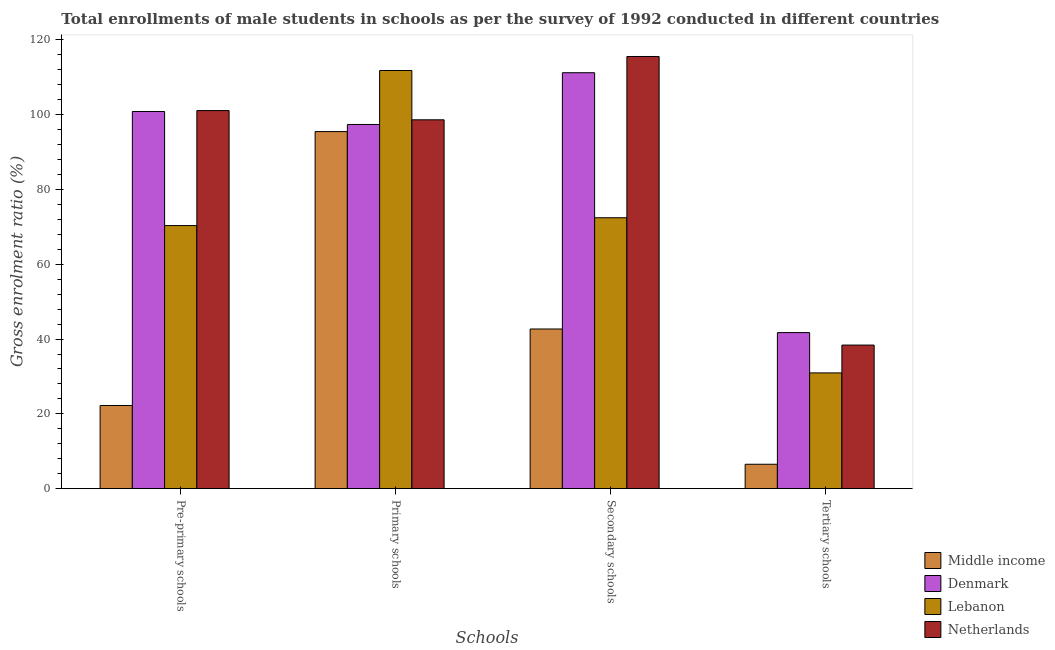What is the label of the 3rd group of bars from the left?
Your response must be concise. Secondary schools. What is the gross enrolment ratio(male) in secondary schools in Netherlands?
Your response must be concise. 115.55. Across all countries, what is the maximum gross enrolment ratio(male) in secondary schools?
Give a very brief answer. 115.55. Across all countries, what is the minimum gross enrolment ratio(male) in secondary schools?
Provide a short and direct response. 42.69. In which country was the gross enrolment ratio(male) in pre-primary schools maximum?
Provide a short and direct response. Netherlands. What is the total gross enrolment ratio(male) in pre-primary schools in the graph?
Make the answer very short. 294.52. What is the difference between the gross enrolment ratio(male) in primary schools in Netherlands and that in Lebanon?
Your answer should be very brief. -13.18. What is the difference between the gross enrolment ratio(male) in primary schools in Lebanon and the gross enrolment ratio(male) in pre-primary schools in Middle income?
Your response must be concise. 89.56. What is the average gross enrolment ratio(male) in secondary schools per country?
Your answer should be very brief. 85.47. What is the difference between the gross enrolment ratio(male) in tertiary schools and gross enrolment ratio(male) in primary schools in Middle income?
Offer a very short reply. -88.94. In how many countries, is the gross enrolment ratio(male) in pre-primary schools greater than 40 %?
Your answer should be very brief. 3. What is the ratio of the gross enrolment ratio(male) in primary schools in Middle income to that in Netherlands?
Make the answer very short. 0.97. Is the gross enrolment ratio(male) in secondary schools in Netherlands less than that in Denmark?
Give a very brief answer. No. Is the difference between the gross enrolment ratio(male) in primary schools in Middle income and Netherlands greater than the difference between the gross enrolment ratio(male) in secondary schools in Middle income and Netherlands?
Provide a short and direct response. Yes. What is the difference between the highest and the second highest gross enrolment ratio(male) in tertiary schools?
Your response must be concise. 3.33. What is the difference between the highest and the lowest gross enrolment ratio(male) in secondary schools?
Provide a short and direct response. 72.86. In how many countries, is the gross enrolment ratio(male) in pre-primary schools greater than the average gross enrolment ratio(male) in pre-primary schools taken over all countries?
Offer a very short reply. 2. Is the sum of the gross enrolment ratio(male) in primary schools in Netherlands and Middle income greater than the maximum gross enrolment ratio(male) in secondary schools across all countries?
Offer a very short reply. Yes. Is it the case that in every country, the sum of the gross enrolment ratio(male) in tertiary schools and gross enrolment ratio(male) in pre-primary schools is greater than the sum of gross enrolment ratio(male) in secondary schools and gross enrolment ratio(male) in primary schools?
Make the answer very short. No. What does the 4th bar from the left in Tertiary schools represents?
Your answer should be compact. Netherlands. Are all the bars in the graph horizontal?
Provide a succinct answer. No. How many countries are there in the graph?
Offer a very short reply. 4. What is the difference between two consecutive major ticks on the Y-axis?
Keep it short and to the point. 20. Does the graph contain grids?
Give a very brief answer. No. Where does the legend appear in the graph?
Keep it short and to the point. Bottom right. How many legend labels are there?
Your answer should be compact. 4. How are the legend labels stacked?
Offer a terse response. Vertical. What is the title of the graph?
Give a very brief answer. Total enrollments of male students in schools as per the survey of 1992 conducted in different countries. Does "Korea (Democratic)" appear as one of the legend labels in the graph?
Give a very brief answer. No. What is the label or title of the X-axis?
Your response must be concise. Schools. What is the Gross enrolment ratio (%) in Middle income in Pre-primary schools?
Provide a succinct answer. 22.24. What is the Gross enrolment ratio (%) in Denmark in Pre-primary schools?
Keep it short and to the point. 100.84. What is the Gross enrolment ratio (%) of Lebanon in Pre-primary schools?
Provide a succinct answer. 70.35. What is the Gross enrolment ratio (%) of Netherlands in Pre-primary schools?
Ensure brevity in your answer.  101.09. What is the Gross enrolment ratio (%) of Middle income in Primary schools?
Provide a short and direct response. 95.47. What is the Gross enrolment ratio (%) of Denmark in Primary schools?
Offer a very short reply. 97.37. What is the Gross enrolment ratio (%) of Lebanon in Primary schools?
Your response must be concise. 111.8. What is the Gross enrolment ratio (%) of Netherlands in Primary schools?
Your answer should be very brief. 98.62. What is the Gross enrolment ratio (%) in Middle income in Secondary schools?
Ensure brevity in your answer.  42.69. What is the Gross enrolment ratio (%) in Denmark in Secondary schools?
Provide a succinct answer. 111.21. What is the Gross enrolment ratio (%) of Lebanon in Secondary schools?
Offer a terse response. 72.44. What is the Gross enrolment ratio (%) in Netherlands in Secondary schools?
Your answer should be compact. 115.55. What is the Gross enrolment ratio (%) in Middle income in Tertiary schools?
Your answer should be very brief. 6.53. What is the Gross enrolment ratio (%) of Denmark in Tertiary schools?
Provide a short and direct response. 41.73. What is the Gross enrolment ratio (%) of Lebanon in Tertiary schools?
Your answer should be very brief. 30.95. What is the Gross enrolment ratio (%) in Netherlands in Tertiary schools?
Offer a terse response. 38.4. Across all Schools, what is the maximum Gross enrolment ratio (%) of Middle income?
Offer a very short reply. 95.47. Across all Schools, what is the maximum Gross enrolment ratio (%) of Denmark?
Ensure brevity in your answer.  111.21. Across all Schools, what is the maximum Gross enrolment ratio (%) of Lebanon?
Offer a terse response. 111.8. Across all Schools, what is the maximum Gross enrolment ratio (%) in Netherlands?
Make the answer very short. 115.55. Across all Schools, what is the minimum Gross enrolment ratio (%) of Middle income?
Give a very brief answer. 6.53. Across all Schools, what is the minimum Gross enrolment ratio (%) in Denmark?
Offer a very short reply. 41.73. Across all Schools, what is the minimum Gross enrolment ratio (%) in Lebanon?
Your response must be concise. 30.95. Across all Schools, what is the minimum Gross enrolment ratio (%) of Netherlands?
Provide a short and direct response. 38.4. What is the total Gross enrolment ratio (%) in Middle income in the graph?
Provide a succinct answer. 166.93. What is the total Gross enrolment ratio (%) of Denmark in the graph?
Ensure brevity in your answer.  351.16. What is the total Gross enrolment ratio (%) of Lebanon in the graph?
Make the answer very short. 285.54. What is the total Gross enrolment ratio (%) of Netherlands in the graph?
Keep it short and to the point. 353.66. What is the difference between the Gross enrolment ratio (%) of Middle income in Pre-primary schools and that in Primary schools?
Offer a very short reply. -73.23. What is the difference between the Gross enrolment ratio (%) of Denmark in Pre-primary schools and that in Primary schools?
Your answer should be compact. 3.47. What is the difference between the Gross enrolment ratio (%) in Lebanon in Pre-primary schools and that in Primary schools?
Your response must be concise. -41.46. What is the difference between the Gross enrolment ratio (%) in Netherlands in Pre-primary schools and that in Primary schools?
Your response must be concise. 2.47. What is the difference between the Gross enrolment ratio (%) in Middle income in Pre-primary schools and that in Secondary schools?
Your response must be concise. -20.45. What is the difference between the Gross enrolment ratio (%) of Denmark in Pre-primary schools and that in Secondary schools?
Give a very brief answer. -10.37. What is the difference between the Gross enrolment ratio (%) in Lebanon in Pre-primary schools and that in Secondary schools?
Provide a short and direct response. -2.09. What is the difference between the Gross enrolment ratio (%) of Netherlands in Pre-primary schools and that in Secondary schools?
Give a very brief answer. -14.46. What is the difference between the Gross enrolment ratio (%) of Middle income in Pre-primary schools and that in Tertiary schools?
Ensure brevity in your answer.  15.71. What is the difference between the Gross enrolment ratio (%) in Denmark in Pre-primary schools and that in Tertiary schools?
Make the answer very short. 59.12. What is the difference between the Gross enrolment ratio (%) of Lebanon in Pre-primary schools and that in Tertiary schools?
Provide a succinct answer. 39.39. What is the difference between the Gross enrolment ratio (%) in Netherlands in Pre-primary schools and that in Tertiary schools?
Your answer should be very brief. 62.69. What is the difference between the Gross enrolment ratio (%) of Middle income in Primary schools and that in Secondary schools?
Your response must be concise. 52.77. What is the difference between the Gross enrolment ratio (%) in Denmark in Primary schools and that in Secondary schools?
Your answer should be compact. -13.84. What is the difference between the Gross enrolment ratio (%) in Lebanon in Primary schools and that in Secondary schools?
Make the answer very short. 39.37. What is the difference between the Gross enrolment ratio (%) of Netherlands in Primary schools and that in Secondary schools?
Provide a succinct answer. -16.93. What is the difference between the Gross enrolment ratio (%) in Middle income in Primary schools and that in Tertiary schools?
Keep it short and to the point. 88.94. What is the difference between the Gross enrolment ratio (%) in Denmark in Primary schools and that in Tertiary schools?
Provide a short and direct response. 55.65. What is the difference between the Gross enrolment ratio (%) of Lebanon in Primary schools and that in Tertiary schools?
Keep it short and to the point. 80.85. What is the difference between the Gross enrolment ratio (%) of Netherlands in Primary schools and that in Tertiary schools?
Provide a short and direct response. 60.23. What is the difference between the Gross enrolment ratio (%) of Middle income in Secondary schools and that in Tertiary schools?
Provide a short and direct response. 36.16. What is the difference between the Gross enrolment ratio (%) in Denmark in Secondary schools and that in Tertiary schools?
Make the answer very short. 69.49. What is the difference between the Gross enrolment ratio (%) in Lebanon in Secondary schools and that in Tertiary schools?
Your response must be concise. 41.48. What is the difference between the Gross enrolment ratio (%) of Netherlands in Secondary schools and that in Tertiary schools?
Ensure brevity in your answer.  77.16. What is the difference between the Gross enrolment ratio (%) in Middle income in Pre-primary schools and the Gross enrolment ratio (%) in Denmark in Primary schools?
Offer a terse response. -75.13. What is the difference between the Gross enrolment ratio (%) of Middle income in Pre-primary schools and the Gross enrolment ratio (%) of Lebanon in Primary schools?
Make the answer very short. -89.56. What is the difference between the Gross enrolment ratio (%) in Middle income in Pre-primary schools and the Gross enrolment ratio (%) in Netherlands in Primary schools?
Make the answer very short. -76.38. What is the difference between the Gross enrolment ratio (%) of Denmark in Pre-primary schools and the Gross enrolment ratio (%) of Lebanon in Primary schools?
Your response must be concise. -10.96. What is the difference between the Gross enrolment ratio (%) of Denmark in Pre-primary schools and the Gross enrolment ratio (%) of Netherlands in Primary schools?
Offer a very short reply. 2.22. What is the difference between the Gross enrolment ratio (%) in Lebanon in Pre-primary schools and the Gross enrolment ratio (%) in Netherlands in Primary schools?
Your response must be concise. -28.28. What is the difference between the Gross enrolment ratio (%) in Middle income in Pre-primary schools and the Gross enrolment ratio (%) in Denmark in Secondary schools?
Make the answer very short. -88.97. What is the difference between the Gross enrolment ratio (%) of Middle income in Pre-primary schools and the Gross enrolment ratio (%) of Lebanon in Secondary schools?
Offer a very short reply. -50.19. What is the difference between the Gross enrolment ratio (%) of Middle income in Pre-primary schools and the Gross enrolment ratio (%) of Netherlands in Secondary schools?
Keep it short and to the point. -93.31. What is the difference between the Gross enrolment ratio (%) of Denmark in Pre-primary schools and the Gross enrolment ratio (%) of Lebanon in Secondary schools?
Keep it short and to the point. 28.41. What is the difference between the Gross enrolment ratio (%) in Denmark in Pre-primary schools and the Gross enrolment ratio (%) in Netherlands in Secondary schools?
Keep it short and to the point. -14.71. What is the difference between the Gross enrolment ratio (%) in Lebanon in Pre-primary schools and the Gross enrolment ratio (%) in Netherlands in Secondary schools?
Make the answer very short. -45.21. What is the difference between the Gross enrolment ratio (%) in Middle income in Pre-primary schools and the Gross enrolment ratio (%) in Denmark in Tertiary schools?
Your response must be concise. -19.49. What is the difference between the Gross enrolment ratio (%) in Middle income in Pre-primary schools and the Gross enrolment ratio (%) in Lebanon in Tertiary schools?
Provide a succinct answer. -8.71. What is the difference between the Gross enrolment ratio (%) of Middle income in Pre-primary schools and the Gross enrolment ratio (%) of Netherlands in Tertiary schools?
Ensure brevity in your answer.  -16.16. What is the difference between the Gross enrolment ratio (%) in Denmark in Pre-primary schools and the Gross enrolment ratio (%) in Lebanon in Tertiary schools?
Provide a succinct answer. 69.89. What is the difference between the Gross enrolment ratio (%) of Denmark in Pre-primary schools and the Gross enrolment ratio (%) of Netherlands in Tertiary schools?
Offer a terse response. 62.45. What is the difference between the Gross enrolment ratio (%) in Lebanon in Pre-primary schools and the Gross enrolment ratio (%) in Netherlands in Tertiary schools?
Ensure brevity in your answer.  31.95. What is the difference between the Gross enrolment ratio (%) of Middle income in Primary schools and the Gross enrolment ratio (%) of Denmark in Secondary schools?
Keep it short and to the point. -15.74. What is the difference between the Gross enrolment ratio (%) of Middle income in Primary schools and the Gross enrolment ratio (%) of Lebanon in Secondary schools?
Make the answer very short. 23.03. What is the difference between the Gross enrolment ratio (%) of Middle income in Primary schools and the Gross enrolment ratio (%) of Netherlands in Secondary schools?
Your response must be concise. -20.08. What is the difference between the Gross enrolment ratio (%) of Denmark in Primary schools and the Gross enrolment ratio (%) of Lebanon in Secondary schools?
Give a very brief answer. 24.94. What is the difference between the Gross enrolment ratio (%) in Denmark in Primary schools and the Gross enrolment ratio (%) in Netherlands in Secondary schools?
Provide a succinct answer. -18.18. What is the difference between the Gross enrolment ratio (%) of Lebanon in Primary schools and the Gross enrolment ratio (%) of Netherlands in Secondary schools?
Offer a terse response. -3.75. What is the difference between the Gross enrolment ratio (%) of Middle income in Primary schools and the Gross enrolment ratio (%) of Denmark in Tertiary schools?
Offer a terse response. 53.74. What is the difference between the Gross enrolment ratio (%) of Middle income in Primary schools and the Gross enrolment ratio (%) of Lebanon in Tertiary schools?
Your answer should be compact. 64.52. What is the difference between the Gross enrolment ratio (%) in Middle income in Primary schools and the Gross enrolment ratio (%) in Netherlands in Tertiary schools?
Offer a very short reply. 57.07. What is the difference between the Gross enrolment ratio (%) in Denmark in Primary schools and the Gross enrolment ratio (%) in Lebanon in Tertiary schools?
Provide a succinct answer. 66.42. What is the difference between the Gross enrolment ratio (%) of Denmark in Primary schools and the Gross enrolment ratio (%) of Netherlands in Tertiary schools?
Give a very brief answer. 58.98. What is the difference between the Gross enrolment ratio (%) in Lebanon in Primary schools and the Gross enrolment ratio (%) in Netherlands in Tertiary schools?
Ensure brevity in your answer.  73.41. What is the difference between the Gross enrolment ratio (%) in Middle income in Secondary schools and the Gross enrolment ratio (%) in Denmark in Tertiary schools?
Offer a terse response. 0.97. What is the difference between the Gross enrolment ratio (%) of Middle income in Secondary schools and the Gross enrolment ratio (%) of Lebanon in Tertiary schools?
Your answer should be compact. 11.74. What is the difference between the Gross enrolment ratio (%) of Middle income in Secondary schools and the Gross enrolment ratio (%) of Netherlands in Tertiary schools?
Ensure brevity in your answer.  4.3. What is the difference between the Gross enrolment ratio (%) of Denmark in Secondary schools and the Gross enrolment ratio (%) of Lebanon in Tertiary schools?
Your answer should be compact. 80.26. What is the difference between the Gross enrolment ratio (%) of Denmark in Secondary schools and the Gross enrolment ratio (%) of Netherlands in Tertiary schools?
Give a very brief answer. 72.82. What is the difference between the Gross enrolment ratio (%) of Lebanon in Secondary schools and the Gross enrolment ratio (%) of Netherlands in Tertiary schools?
Provide a succinct answer. 34.04. What is the average Gross enrolment ratio (%) in Middle income per Schools?
Offer a terse response. 41.73. What is the average Gross enrolment ratio (%) in Denmark per Schools?
Keep it short and to the point. 87.79. What is the average Gross enrolment ratio (%) of Lebanon per Schools?
Provide a short and direct response. 71.38. What is the average Gross enrolment ratio (%) in Netherlands per Schools?
Give a very brief answer. 88.41. What is the difference between the Gross enrolment ratio (%) of Middle income and Gross enrolment ratio (%) of Denmark in Pre-primary schools?
Your answer should be compact. -78.6. What is the difference between the Gross enrolment ratio (%) in Middle income and Gross enrolment ratio (%) in Lebanon in Pre-primary schools?
Keep it short and to the point. -48.11. What is the difference between the Gross enrolment ratio (%) of Middle income and Gross enrolment ratio (%) of Netherlands in Pre-primary schools?
Ensure brevity in your answer.  -78.85. What is the difference between the Gross enrolment ratio (%) in Denmark and Gross enrolment ratio (%) in Lebanon in Pre-primary schools?
Your answer should be very brief. 30.5. What is the difference between the Gross enrolment ratio (%) of Denmark and Gross enrolment ratio (%) of Netherlands in Pre-primary schools?
Keep it short and to the point. -0.25. What is the difference between the Gross enrolment ratio (%) of Lebanon and Gross enrolment ratio (%) of Netherlands in Pre-primary schools?
Ensure brevity in your answer.  -30.74. What is the difference between the Gross enrolment ratio (%) of Middle income and Gross enrolment ratio (%) of Denmark in Primary schools?
Give a very brief answer. -1.9. What is the difference between the Gross enrolment ratio (%) of Middle income and Gross enrolment ratio (%) of Lebanon in Primary schools?
Provide a short and direct response. -16.33. What is the difference between the Gross enrolment ratio (%) of Middle income and Gross enrolment ratio (%) of Netherlands in Primary schools?
Your answer should be very brief. -3.15. What is the difference between the Gross enrolment ratio (%) of Denmark and Gross enrolment ratio (%) of Lebanon in Primary schools?
Offer a terse response. -14.43. What is the difference between the Gross enrolment ratio (%) of Denmark and Gross enrolment ratio (%) of Netherlands in Primary schools?
Your response must be concise. -1.25. What is the difference between the Gross enrolment ratio (%) of Lebanon and Gross enrolment ratio (%) of Netherlands in Primary schools?
Offer a terse response. 13.18. What is the difference between the Gross enrolment ratio (%) of Middle income and Gross enrolment ratio (%) of Denmark in Secondary schools?
Your answer should be compact. -68.52. What is the difference between the Gross enrolment ratio (%) of Middle income and Gross enrolment ratio (%) of Lebanon in Secondary schools?
Ensure brevity in your answer.  -29.74. What is the difference between the Gross enrolment ratio (%) of Middle income and Gross enrolment ratio (%) of Netherlands in Secondary schools?
Give a very brief answer. -72.86. What is the difference between the Gross enrolment ratio (%) of Denmark and Gross enrolment ratio (%) of Lebanon in Secondary schools?
Make the answer very short. 38.78. What is the difference between the Gross enrolment ratio (%) of Denmark and Gross enrolment ratio (%) of Netherlands in Secondary schools?
Keep it short and to the point. -4.34. What is the difference between the Gross enrolment ratio (%) in Lebanon and Gross enrolment ratio (%) in Netherlands in Secondary schools?
Provide a short and direct response. -43.12. What is the difference between the Gross enrolment ratio (%) of Middle income and Gross enrolment ratio (%) of Denmark in Tertiary schools?
Your answer should be compact. -35.2. What is the difference between the Gross enrolment ratio (%) in Middle income and Gross enrolment ratio (%) in Lebanon in Tertiary schools?
Ensure brevity in your answer.  -24.42. What is the difference between the Gross enrolment ratio (%) of Middle income and Gross enrolment ratio (%) of Netherlands in Tertiary schools?
Provide a short and direct response. -31.87. What is the difference between the Gross enrolment ratio (%) of Denmark and Gross enrolment ratio (%) of Lebanon in Tertiary schools?
Provide a short and direct response. 10.77. What is the difference between the Gross enrolment ratio (%) in Denmark and Gross enrolment ratio (%) in Netherlands in Tertiary schools?
Your answer should be very brief. 3.33. What is the difference between the Gross enrolment ratio (%) of Lebanon and Gross enrolment ratio (%) of Netherlands in Tertiary schools?
Provide a succinct answer. -7.44. What is the ratio of the Gross enrolment ratio (%) of Middle income in Pre-primary schools to that in Primary schools?
Your response must be concise. 0.23. What is the ratio of the Gross enrolment ratio (%) of Denmark in Pre-primary schools to that in Primary schools?
Give a very brief answer. 1.04. What is the ratio of the Gross enrolment ratio (%) in Lebanon in Pre-primary schools to that in Primary schools?
Make the answer very short. 0.63. What is the ratio of the Gross enrolment ratio (%) of Middle income in Pre-primary schools to that in Secondary schools?
Make the answer very short. 0.52. What is the ratio of the Gross enrolment ratio (%) of Denmark in Pre-primary schools to that in Secondary schools?
Your answer should be compact. 0.91. What is the ratio of the Gross enrolment ratio (%) in Lebanon in Pre-primary schools to that in Secondary schools?
Ensure brevity in your answer.  0.97. What is the ratio of the Gross enrolment ratio (%) of Netherlands in Pre-primary schools to that in Secondary schools?
Provide a short and direct response. 0.87. What is the ratio of the Gross enrolment ratio (%) in Middle income in Pre-primary schools to that in Tertiary schools?
Offer a terse response. 3.41. What is the ratio of the Gross enrolment ratio (%) in Denmark in Pre-primary schools to that in Tertiary schools?
Provide a succinct answer. 2.42. What is the ratio of the Gross enrolment ratio (%) in Lebanon in Pre-primary schools to that in Tertiary schools?
Provide a succinct answer. 2.27. What is the ratio of the Gross enrolment ratio (%) in Netherlands in Pre-primary schools to that in Tertiary schools?
Offer a very short reply. 2.63. What is the ratio of the Gross enrolment ratio (%) in Middle income in Primary schools to that in Secondary schools?
Your answer should be compact. 2.24. What is the ratio of the Gross enrolment ratio (%) of Denmark in Primary schools to that in Secondary schools?
Offer a very short reply. 0.88. What is the ratio of the Gross enrolment ratio (%) in Lebanon in Primary schools to that in Secondary schools?
Offer a very short reply. 1.54. What is the ratio of the Gross enrolment ratio (%) of Netherlands in Primary schools to that in Secondary schools?
Make the answer very short. 0.85. What is the ratio of the Gross enrolment ratio (%) of Middle income in Primary schools to that in Tertiary schools?
Ensure brevity in your answer.  14.62. What is the ratio of the Gross enrolment ratio (%) in Denmark in Primary schools to that in Tertiary schools?
Your answer should be compact. 2.33. What is the ratio of the Gross enrolment ratio (%) in Lebanon in Primary schools to that in Tertiary schools?
Offer a terse response. 3.61. What is the ratio of the Gross enrolment ratio (%) in Netherlands in Primary schools to that in Tertiary schools?
Make the answer very short. 2.57. What is the ratio of the Gross enrolment ratio (%) in Middle income in Secondary schools to that in Tertiary schools?
Your response must be concise. 6.54. What is the ratio of the Gross enrolment ratio (%) in Denmark in Secondary schools to that in Tertiary schools?
Your answer should be compact. 2.67. What is the ratio of the Gross enrolment ratio (%) in Lebanon in Secondary schools to that in Tertiary schools?
Provide a short and direct response. 2.34. What is the ratio of the Gross enrolment ratio (%) of Netherlands in Secondary schools to that in Tertiary schools?
Your response must be concise. 3.01. What is the difference between the highest and the second highest Gross enrolment ratio (%) in Middle income?
Make the answer very short. 52.77. What is the difference between the highest and the second highest Gross enrolment ratio (%) in Denmark?
Provide a short and direct response. 10.37. What is the difference between the highest and the second highest Gross enrolment ratio (%) of Lebanon?
Give a very brief answer. 39.37. What is the difference between the highest and the second highest Gross enrolment ratio (%) of Netherlands?
Make the answer very short. 14.46. What is the difference between the highest and the lowest Gross enrolment ratio (%) in Middle income?
Ensure brevity in your answer.  88.94. What is the difference between the highest and the lowest Gross enrolment ratio (%) in Denmark?
Your answer should be very brief. 69.49. What is the difference between the highest and the lowest Gross enrolment ratio (%) of Lebanon?
Provide a succinct answer. 80.85. What is the difference between the highest and the lowest Gross enrolment ratio (%) in Netherlands?
Your response must be concise. 77.16. 